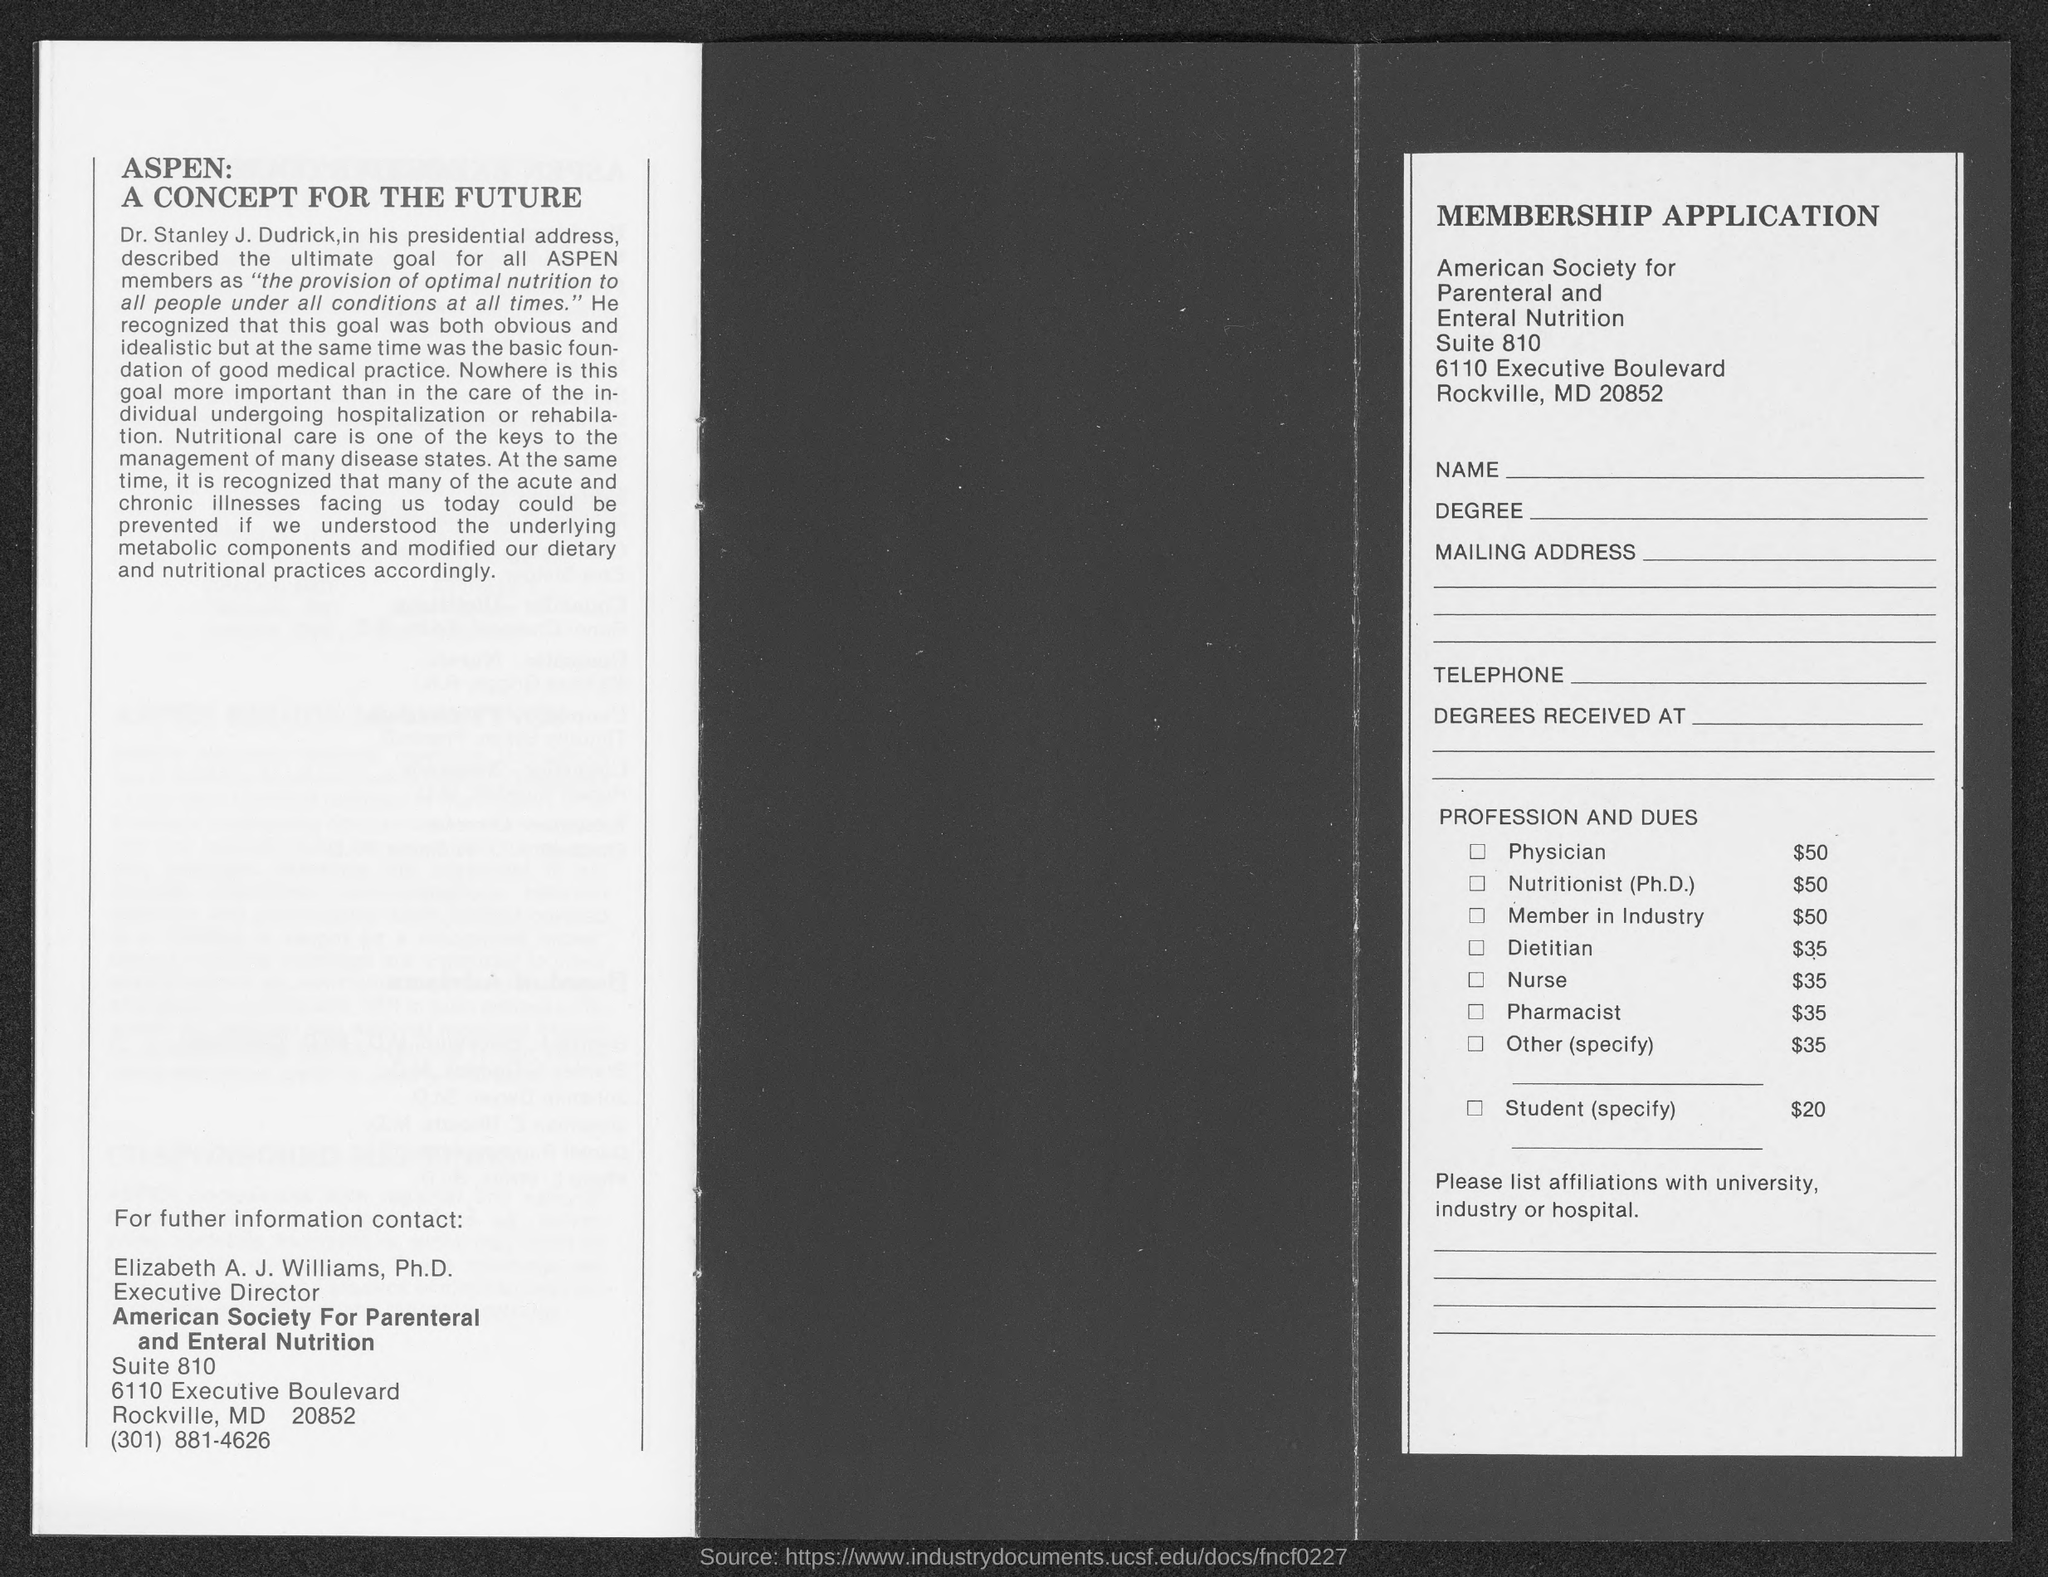Point out several critical features in this image. Nutritional care is the key to effectively managing multiple disease states. The ultimate goal of all ASPEN members is to ensure the provision of optimal nutrition to all people, under all conditions, and at all times. 